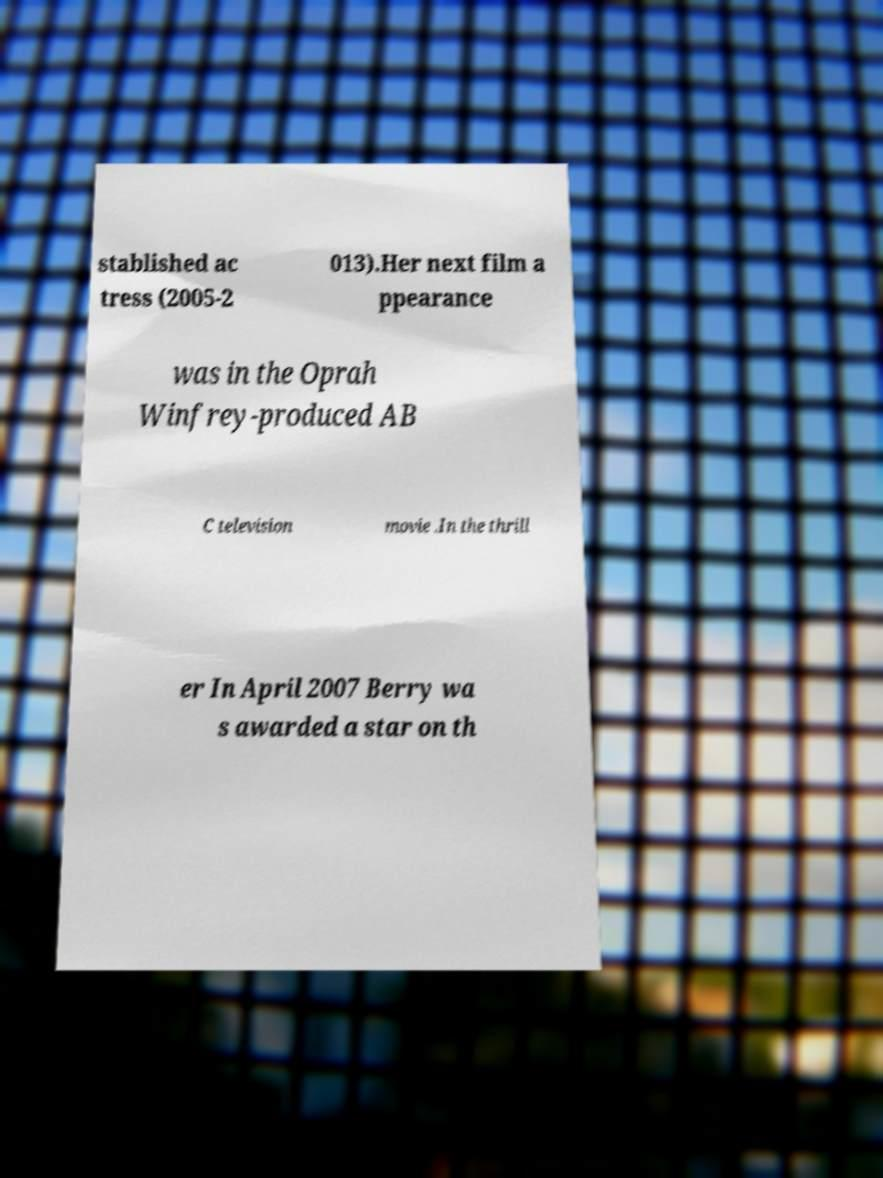For documentation purposes, I need the text within this image transcribed. Could you provide that? stablished ac tress (2005-2 013).Her next film a ppearance was in the Oprah Winfrey-produced AB C television movie .In the thrill er In April 2007 Berry wa s awarded a star on th 